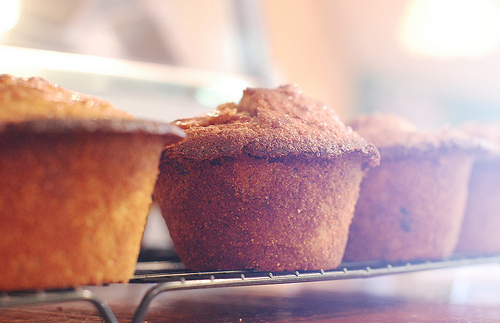<image>
Is the muffin on the rack? Yes. Looking at the image, I can see the muffin is positioned on top of the rack, with the rack providing support. Is the cupcake above the grate? No. The cupcake is not positioned above the grate. The vertical arrangement shows a different relationship. 